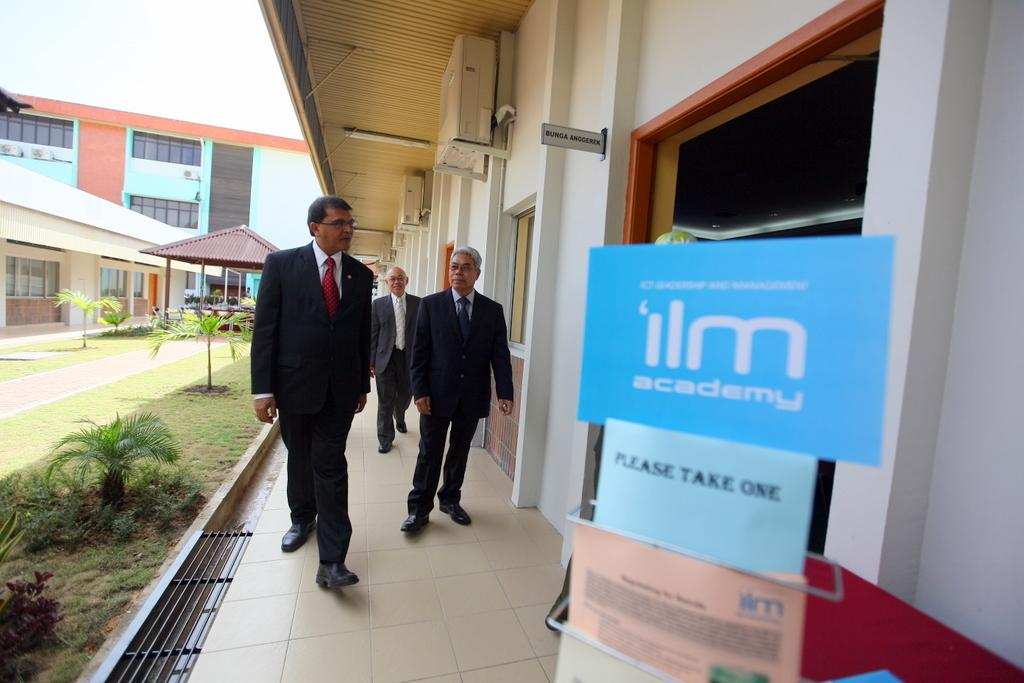<image>
Provide a brief description of the given image. Three men in suits walking towards an ilm academy sign. 